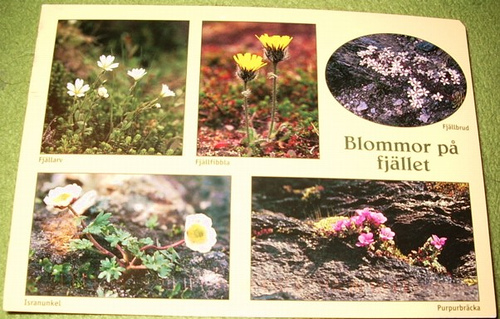<image>
Is the flower in the pamphlet? Yes. The flower is contained within or inside the pamphlet, showing a containment relationship. 